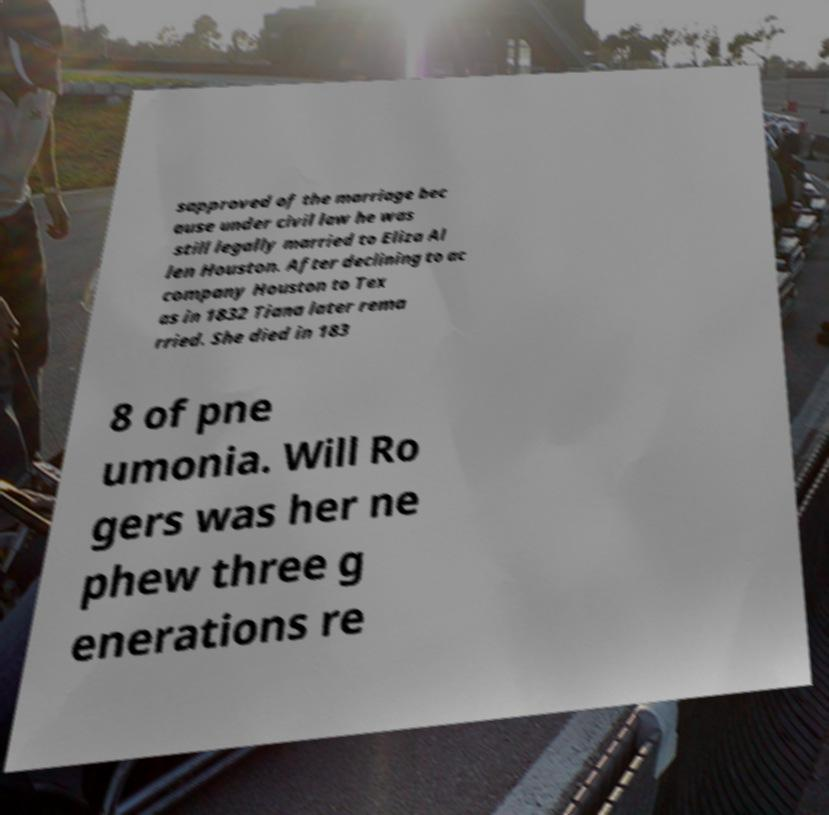Could you assist in decoding the text presented in this image and type it out clearly? sapproved of the marriage bec ause under civil law he was still legally married to Eliza Al len Houston. After declining to ac company Houston to Tex as in 1832 Tiana later rema rried. She died in 183 8 of pne umonia. Will Ro gers was her ne phew three g enerations re 